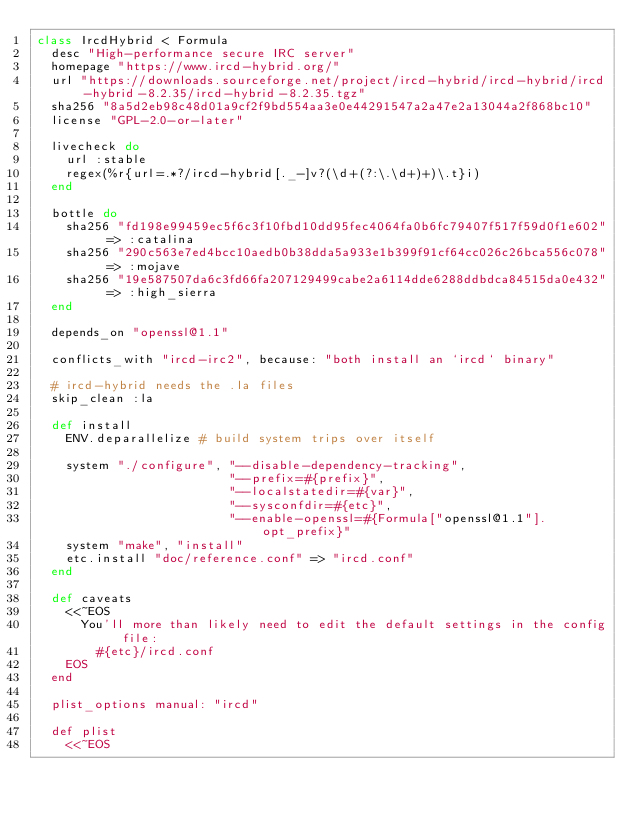Convert code to text. <code><loc_0><loc_0><loc_500><loc_500><_Ruby_>class IrcdHybrid < Formula
  desc "High-performance secure IRC server"
  homepage "https://www.ircd-hybrid.org/"
  url "https://downloads.sourceforge.net/project/ircd-hybrid/ircd-hybrid/ircd-hybrid-8.2.35/ircd-hybrid-8.2.35.tgz"
  sha256 "8a5d2eb98c48d01a9cf2f9bd554aa3e0e44291547a2a47e2a13044a2f868bc10"
  license "GPL-2.0-or-later"

  livecheck do
    url :stable
    regex(%r{url=.*?/ircd-hybrid[._-]v?(\d+(?:\.\d+)+)\.t}i)
  end

  bottle do
    sha256 "fd198e99459ec5f6c3f10fbd10dd95fec4064fa0b6fc79407f517f59d0f1e602" => :catalina
    sha256 "290c563e7ed4bcc10aedb0b38dda5a933e1b399f91cf64cc026c26bca556c078" => :mojave
    sha256 "19e587507da6c3fd66fa207129499cabe2a6114dde6288ddbdca84515da0e432" => :high_sierra
  end

  depends_on "openssl@1.1"

  conflicts_with "ircd-irc2", because: "both install an `ircd` binary"

  # ircd-hybrid needs the .la files
  skip_clean :la

  def install
    ENV.deparallelize # build system trips over itself

    system "./configure", "--disable-dependency-tracking",
                          "--prefix=#{prefix}",
                          "--localstatedir=#{var}",
                          "--sysconfdir=#{etc}",
                          "--enable-openssl=#{Formula["openssl@1.1"].opt_prefix}"
    system "make", "install"
    etc.install "doc/reference.conf" => "ircd.conf"
  end

  def caveats
    <<~EOS
      You'll more than likely need to edit the default settings in the config file:
        #{etc}/ircd.conf
    EOS
  end

  plist_options manual: "ircd"

  def plist
    <<~EOS</code> 